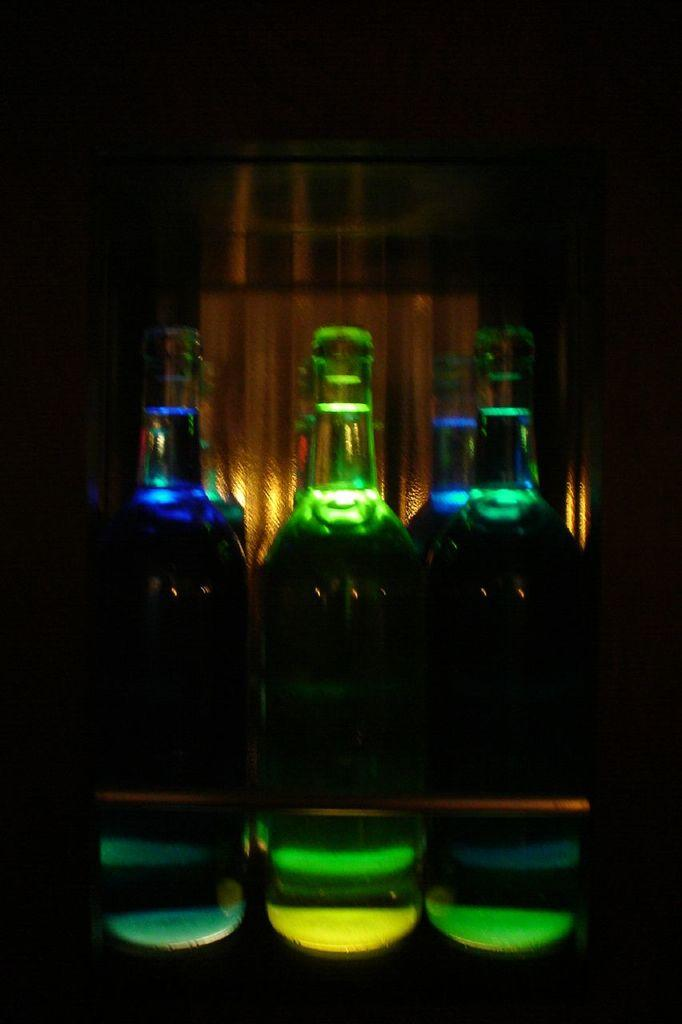What objects can be seen in the image? There are bottles in the image. Can you describe the bottles in more detail? The bottles are of different colors. Are there any cherries on top of the bottles in the image? There is no mention of cherries in the provided facts, and therefore we cannot determine if they are present in the image. 